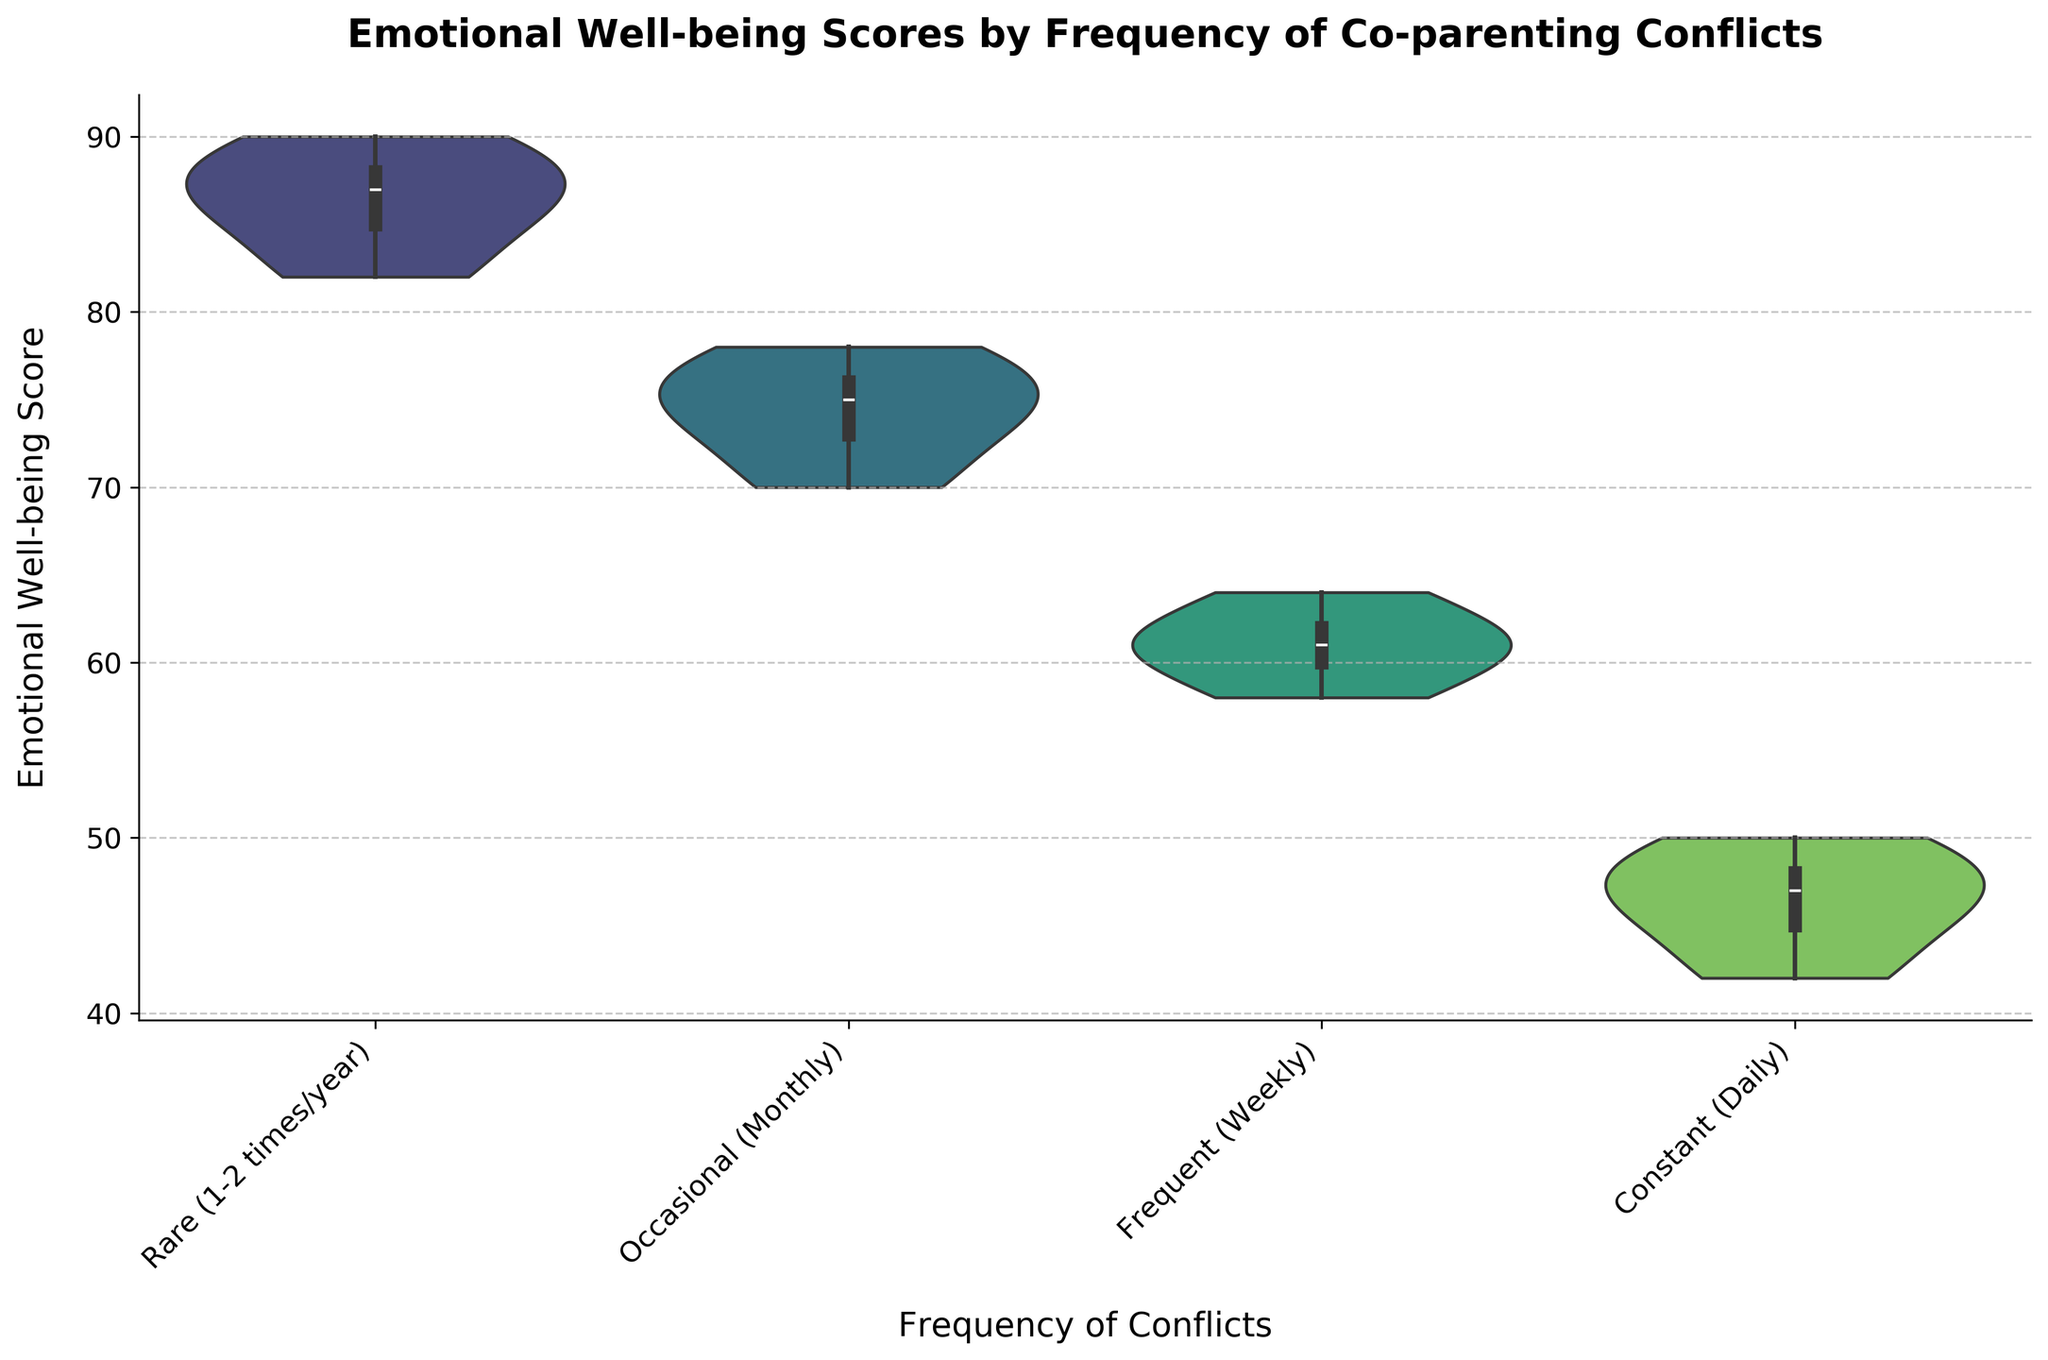What is the title of the figure? The title of the figure is usually located at the top center and is provided to give an overview of what the chart is about.
Answer: Emotional Well-being Scores by Frequency of Co-parenting Conflicts What is the median Emotional Well-being Score for co-parents with 'Rare (1-2 times/year)' conflicts? Medians can be identified in violin charts via the central horizontal line inside the inner box plot of each violin section.
Answer: 87 Which group has the widest range of Emotional Well-being Scores? The range of scores can be estimated by looking at the vertical span of the violin shapes. The group with the longest vertical span represents the widest range.
Answer: Rare (1-2 times/year) How do the Emotional Well-being Scores generally change as the frequency of conflicts increases? By comparing the central positions and overall shapes of the violins from 'Rare' to 'Constant', we can see the trend in scores. The scores are highest at 'Rare' and decrease progressively with more frequent conflicts.
Answer: Scores decrease with more frequent conflicts What is the comparison between the median scores of 'Occasional (Monthly)' and 'Frequent (Weekly)' conflicts? To compare medians, locate the central lines of the box plots within each respective violin shape and compare their positions.
Answer: Occasional (Monthly) is higher than Frequent (Weekly) Which frequency category has the lowest median Emotional Well-being Score? The lowest median score is identified by the central line of the box plot that is closest to the bottom of the y-axis scale across all the categories.
Answer: Constant (Daily) What is the general shape of the distribution for 'Frequent (Weekly)' conflicts? The shape of the violin plot gives insight into the distribution. Look at the symmetry and spread of the plot around the median line.
Answer: Slightly bimodal How does the interquartile range (IQR) of 'Rare (1-2 times/year)' compare to 'Constant (Daily)'? IQR can be visually estimated by the height of the box plot within each violin. Compare the height of each box plot for the respective groups.
Answer: Rare (1-2 times/year) has a wider IQR than Constant (Daily) Which group shows the most concentration around the median score? The concentration around the median is visualized by the thickness around the central part of the violin shape. Look for the narrowest and most uniform parts around the median line.
Answer: Constant (Daily) What can we infer about the variation in Emotional Well-being Scores for 'Occasional (Monthly)' conflicts from the violin plot? The variation is inferred from the width and overall shape of the violin plot. A wide central area suggests higher variation and spread of scores.
Answer: There is moderate variation 